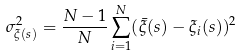Convert formula to latex. <formula><loc_0><loc_0><loc_500><loc_500>\sigma _ { \xi ( s ) } ^ { 2 } = \frac { N - 1 } { N } \sum ^ { N } _ { i = 1 } ( \bar { \xi } ( s ) - \xi _ { i } ( s ) ) ^ { 2 }</formula> 